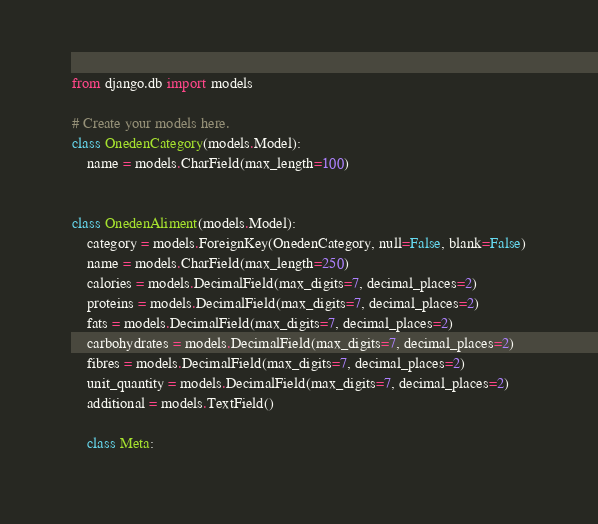<code> <loc_0><loc_0><loc_500><loc_500><_Python_>from django.db import models

# Create your models here.
class OnedenCategory(models.Model):
	name = models.CharField(max_length=100)


class OnedenAliment(models.Model):
	category = models.ForeignKey(OnedenCategory, null=False, blank=False)
	name = models.CharField(max_length=250)
	calories = models.DecimalField(max_digits=7, decimal_places=2)
	proteins = models.DecimalField(max_digits=7, decimal_places=2)
	fats = models.DecimalField(max_digits=7, decimal_places=2)
	carbohydrates = models.DecimalField(max_digits=7, decimal_places=2)
	fibres = models.DecimalField(max_digits=7, decimal_places=2)
	unit_quantity = models.DecimalField(max_digits=7, decimal_places=2)
	additional = models.TextField()

	class Meta:</code> 